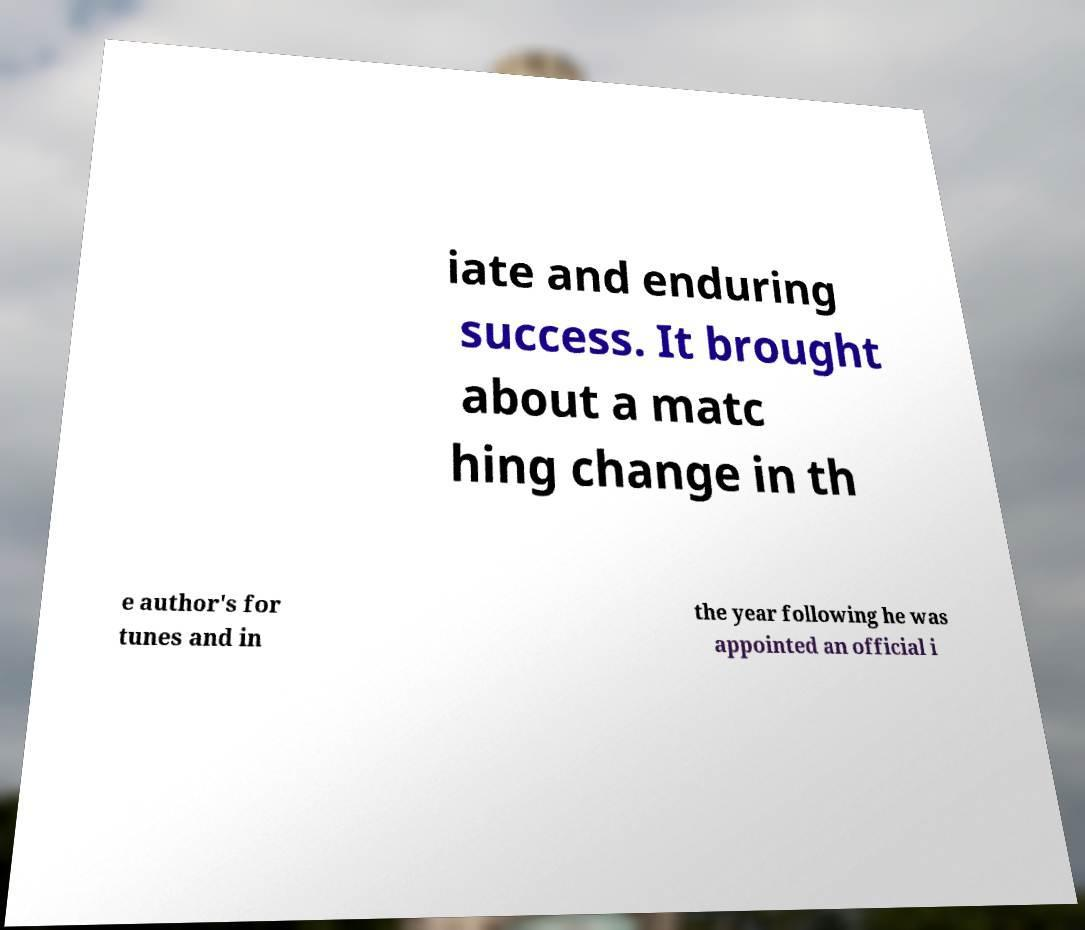Please read and relay the text visible in this image. What does it say? iate and enduring success. It brought about a matc hing change in th e author's for tunes and in the year following he was appointed an official i 